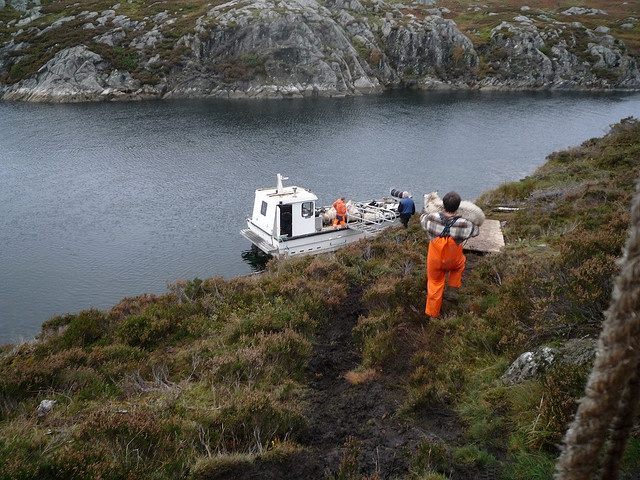Describe the objects in this image and their specific colors. I can see boat in gray, lightgray, darkgray, and black tones, people in gray, brown, red, and black tones, sheep in gray, darkgray, and lightgray tones, people in gray, black, navy, and darkblue tones, and people in gray, salmon, and brown tones in this image. 